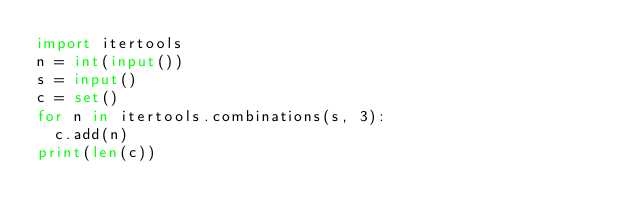<code> <loc_0><loc_0><loc_500><loc_500><_Python_>import itertools
n = int(input())
s = input()
c = set()
for n in itertools.combinations(s, 3):
  c.add(n)
print(len(c))</code> 